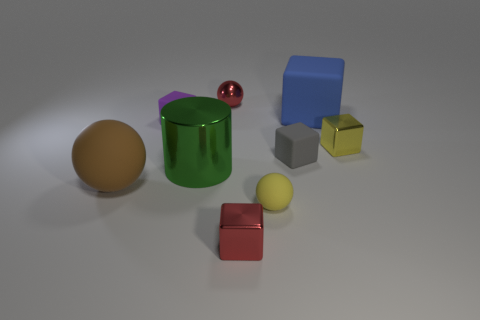Subtract all gray cubes. How many cubes are left? 4 Subtract all blue cubes. How many cubes are left? 4 Subtract 1 spheres. How many spheres are left? 2 Subtract all red blocks. Subtract all cyan cylinders. How many blocks are left? 4 Add 1 green metal objects. How many objects exist? 10 Subtract all blocks. How many objects are left? 4 Subtract 1 red balls. How many objects are left? 8 Subtract all green objects. Subtract all matte spheres. How many objects are left? 6 Add 5 big objects. How many big objects are left? 8 Add 6 large yellow metallic cubes. How many large yellow metallic cubes exist? 6 